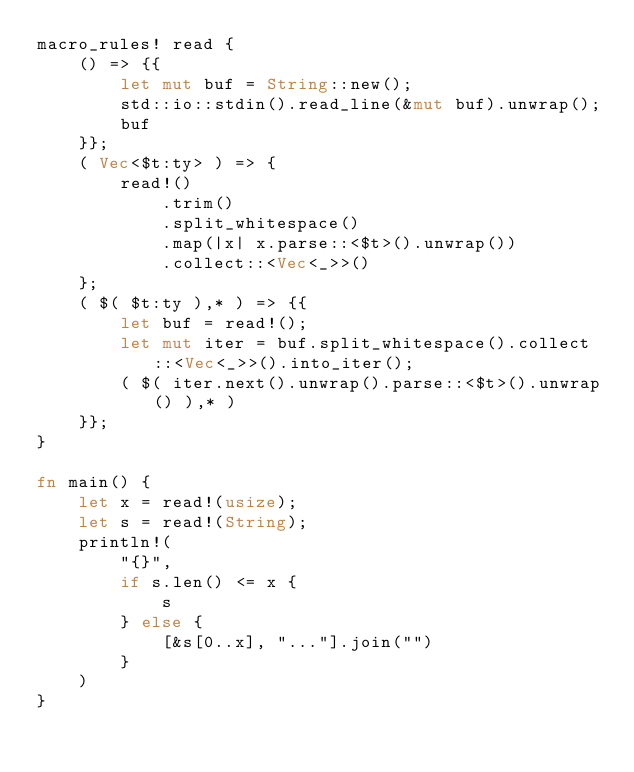<code> <loc_0><loc_0><loc_500><loc_500><_Rust_>macro_rules! read {
    () => {{
        let mut buf = String::new();
        std::io::stdin().read_line(&mut buf).unwrap();
        buf
    }};
    ( Vec<$t:ty> ) => {
        read!()
            .trim()
            .split_whitespace()
            .map(|x| x.parse::<$t>().unwrap())
            .collect::<Vec<_>>()
    };
    ( $( $t:ty ),* ) => {{
        let buf = read!();
        let mut iter = buf.split_whitespace().collect::<Vec<_>>().into_iter();
        ( $( iter.next().unwrap().parse::<$t>().unwrap() ),* )
    }};
}

fn main() {
    let x = read!(usize);
    let s = read!(String);
    println!(
        "{}",
        if s.len() <= x {
            s
        } else {
            [&s[0..x], "..."].join("")
        }
    )
}
</code> 